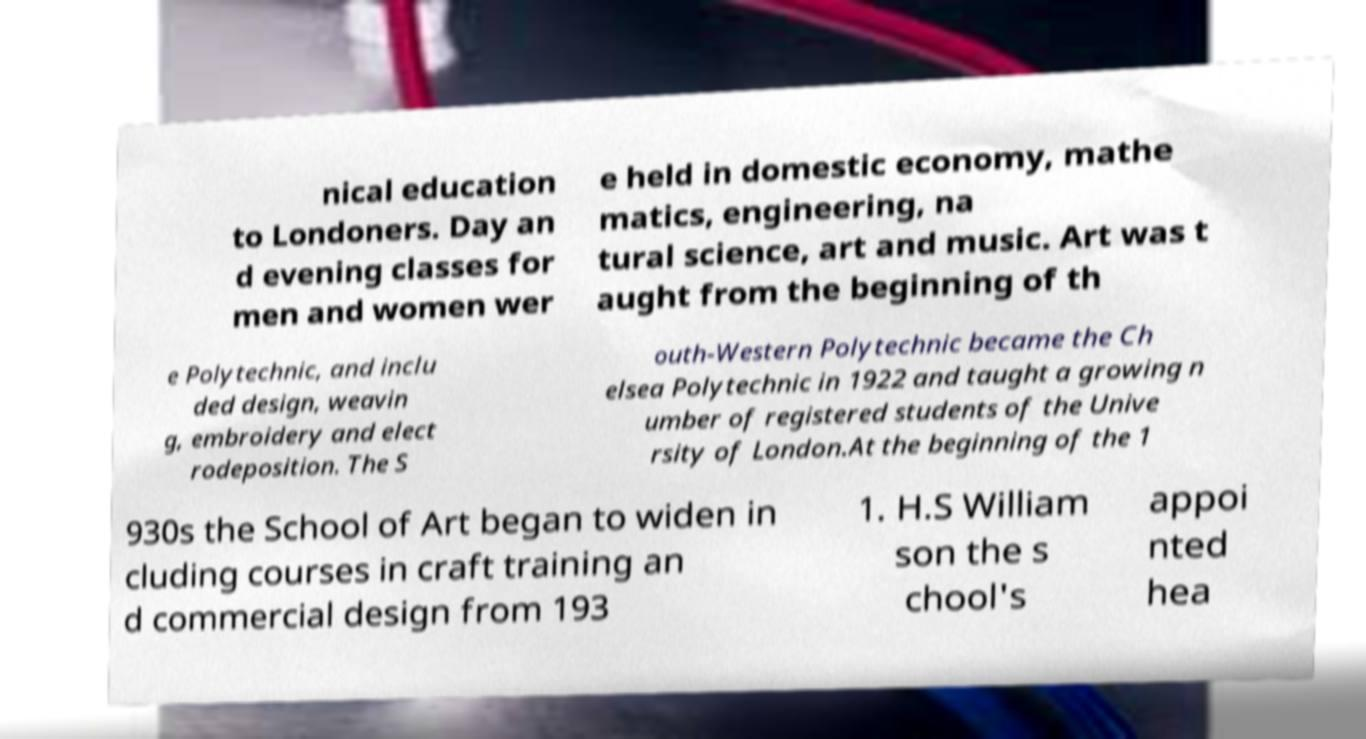For documentation purposes, I need the text within this image transcribed. Could you provide that? nical education to Londoners. Day an d evening classes for men and women wer e held in domestic economy, mathe matics, engineering, na tural science, art and music. Art was t aught from the beginning of th e Polytechnic, and inclu ded design, weavin g, embroidery and elect rodeposition. The S outh-Western Polytechnic became the Ch elsea Polytechnic in 1922 and taught a growing n umber of registered students of the Unive rsity of London.At the beginning of the 1 930s the School of Art began to widen in cluding courses in craft training an d commercial design from 193 1. H.S William son the s chool's appoi nted hea 